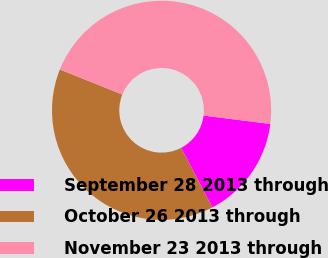Convert chart to OTSL. <chart><loc_0><loc_0><loc_500><loc_500><pie_chart><fcel>September 28 2013 through<fcel>October 26 2013 through<fcel>November 23 2013 through<nl><fcel>15.35%<fcel>38.74%<fcel>45.91%<nl></chart> 